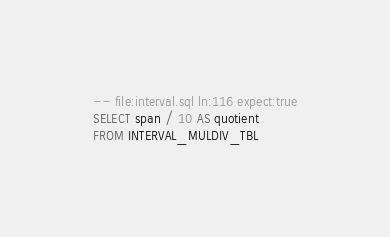<code> <loc_0><loc_0><loc_500><loc_500><_SQL_>-- file:interval.sql ln:116 expect:true
SELECT span / 10 AS quotient
FROM INTERVAL_MULDIV_TBL
</code> 